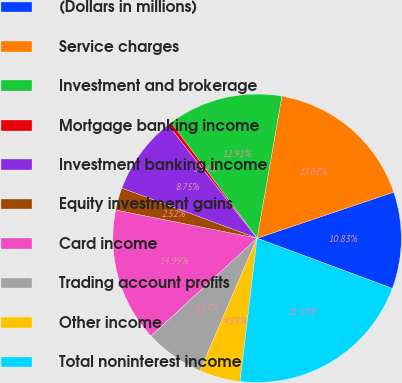Convert chart to OTSL. <chart><loc_0><loc_0><loc_500><loc_500><pie_chart><fcel>(Dollars in millions)<fcel>Service charges<fcel>Investment and brokerage<fcel>Mortgage banking income<fcel>Investment banking income<fcel>Equity investment gains<fcel>Card income<fcel>Trading account profits<fcel>Other income<fcel>Total noninterest income<nl><fcel>10.83%<fcel>17.07%<fcel>12.91%<fcel>0.44%<fcel>8.75%<fcel>2.52%<fcel>14.99%<fcel>6.67%<fcel>4.59%<fcel>21.23%<nl></chart> 